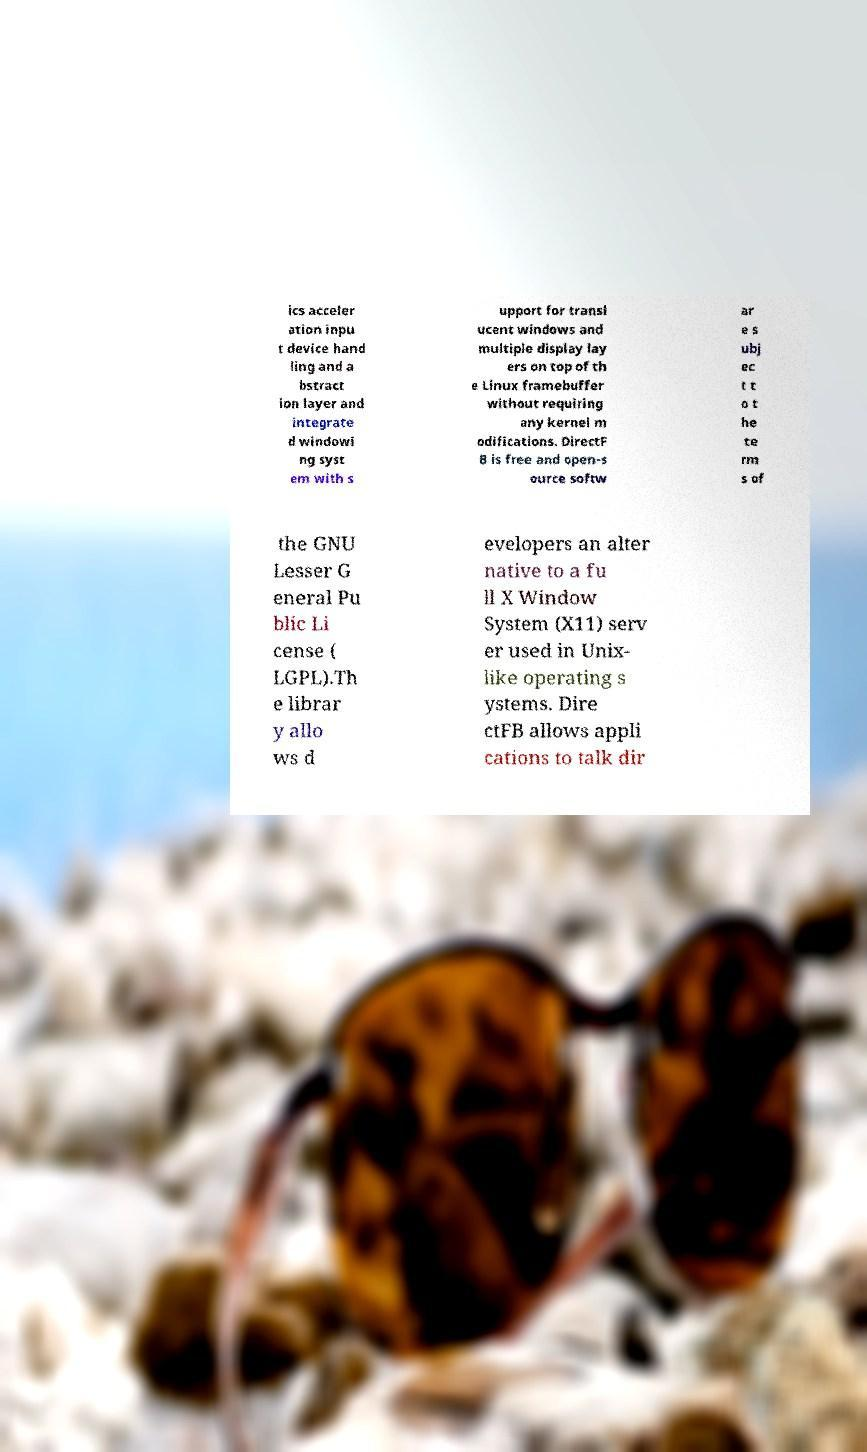Please read and relay the text visible in this image. What does it say? ics acceler ation inpu t device hand ling and a bstract ion layer and integrate d windowi ng syst em with s upport for transl ucent windows and multiple display lay ers on top of th e Linux framebuffer without requiring any kernel m odifications. DirectF B is free and open-s ource softw ar e s ubj ec t t o t he te rm s of the GNU Lesser G eneral Pu blic Li cense ( LGPL).Th e librar y allo ws d evelopers an alter native to a fu ll X Window System (X11) serv er used in Unix- like operating s ystems. Dire ctFB allows appli cations to talk dir 